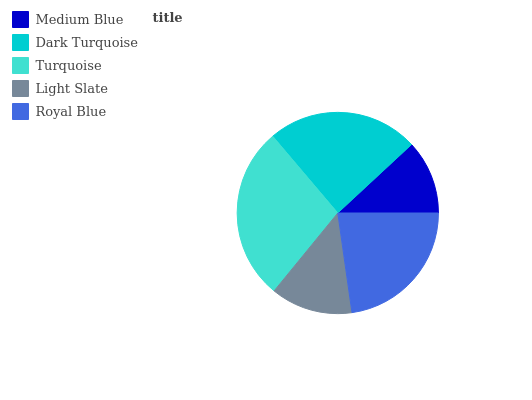Is Medium Blue the minimum?
Answer yes or no. Yes. Is Turquoise the maximum?
Answer yes or no. Yes. Is Dark Turquoise the minimum?
Answer yes or no. No. Is Dark Turquoise the maximum?
Answer yes or no. No. Is Dark Turquoise greater than Medium Blue?
Answer yes or no. Yes. Is Medium Blue less than Dark Turquoise?
Answer yes or no. Yes. Is Medium Blue greater than Dark Turquoise?
Answer yes or no. No. Is Dark Turquoise less than Medium Blue?
Answer yes or no. No. Is Royal Blue the high median?
Answer yes or no. Yes. Is Royal Blue the low median?
Answer yes or no. Yes. Is Medium Blue the high median?
Answer yes or no. No. Is Turquoise the low median?
Answer yes or no. No. 